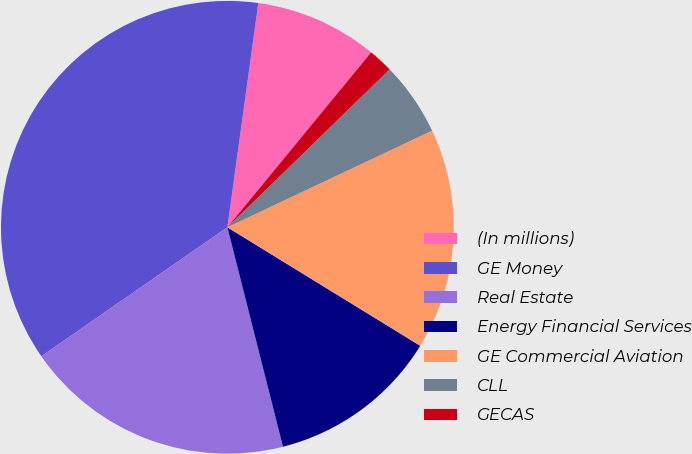Convert chart to OTSL. <chart><loc_0><loc_0><loc_500><loc_500><pie_chart><fcel>(In millions)<fcel>GE Money<fcel>Real Estate<fcel>Energy Financial Services<fcel>GE Commercial Aviation<fcel>CLL<fcel>GECAS<nl><fcel>8.77%<fcel>36.83%<fcel>19.3%<fcel>12.28%<fcel>15.79%<fcel>5.27%<fcel>1.76%<nl></chart> 